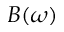Convert formula to latex. <formula><loc_0><loc_0><loc_500><loc_500>B ( \omega )</formula> 